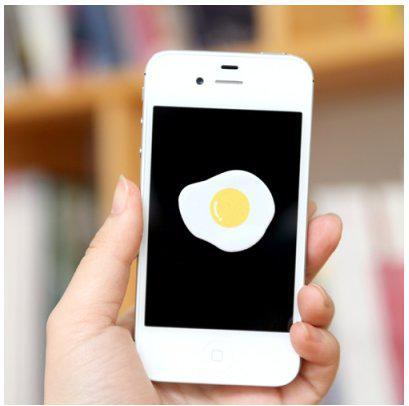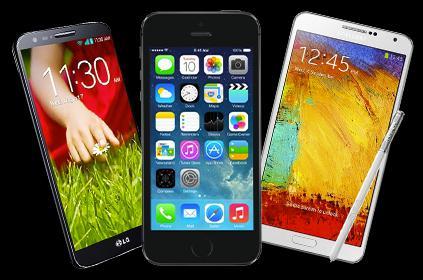The first image is the image on the left, the second image is the image on the right. Analyze the images presented: Is the assertion "There are exactly two phones in total." valid? Answer yes or no. No. The first image is the image on the left, the second image is the image on the right. Assess this claim about the two images: "The right image contains a human hand holding a smart phone.". Correct or not? Answer yes or no. No. 